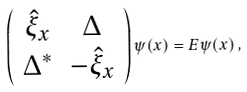Convert formula to latex. <formula><loc_0><loc_0><loc_500><loc_500>\left ( \begin{array} { c c } \hat { \xi } _ { x } & \Delta \\ \Delta ^ { * } & - \hat { \xi } _ { x } \end{array} \right ) \psi ( x ) = E \psi ( x ) \, ,</formula> 